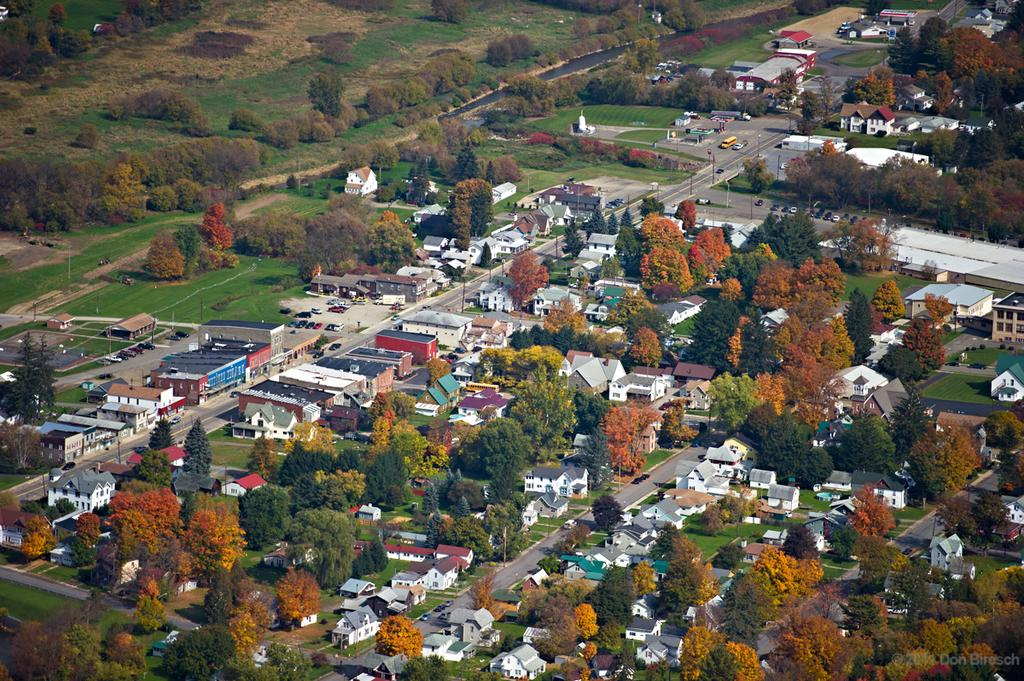What type of view is shown in the image? The image is an aerial view. What can be seen in the image from this perspective? There are many buildings, trees, roads, and vehicles visible in the image. Can you describe the layout of the area shown in the image? The image shows a densely populated area with buildings, trees, and roads intersecting. What might be the purpose of the roads in the image? The roads in the image are likely used for transportation and connecting different parts of the area. What role does the maid play in the image? There is no maid present in the image. How does the army contribute to the scene in the image? There is no army or military presence depicted in the image. 